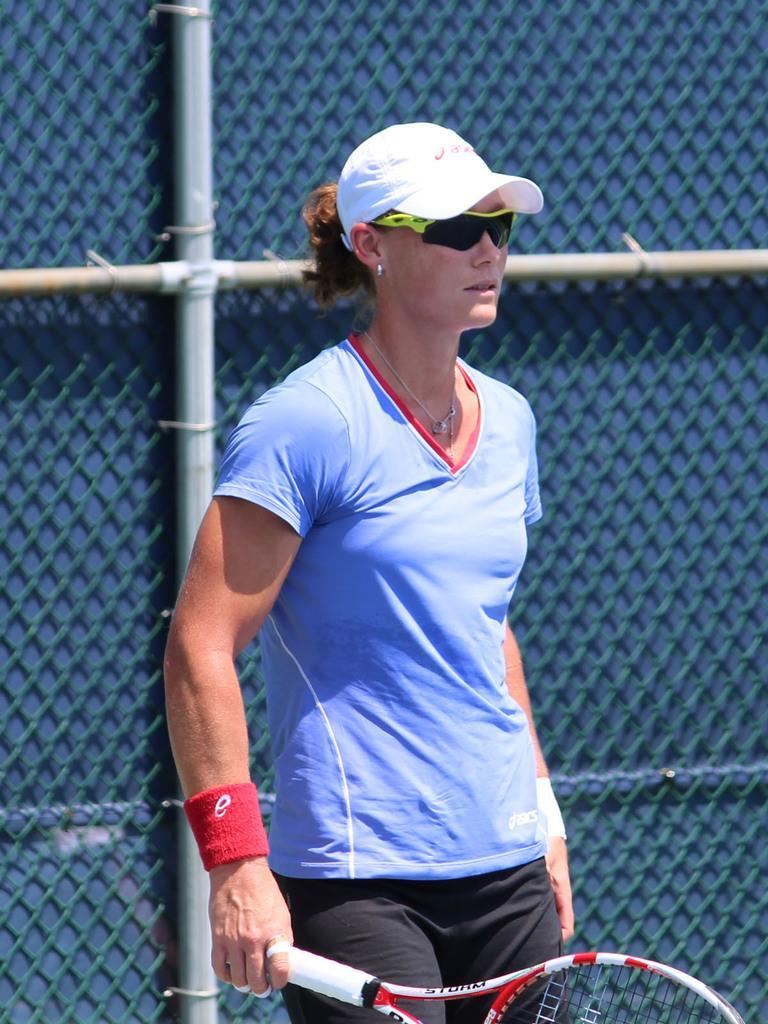In one or two sentences, can you explain what this image depicts? In the middle of the image a woman is standing and holding a tennis racket. Behind her there is a fencing. 